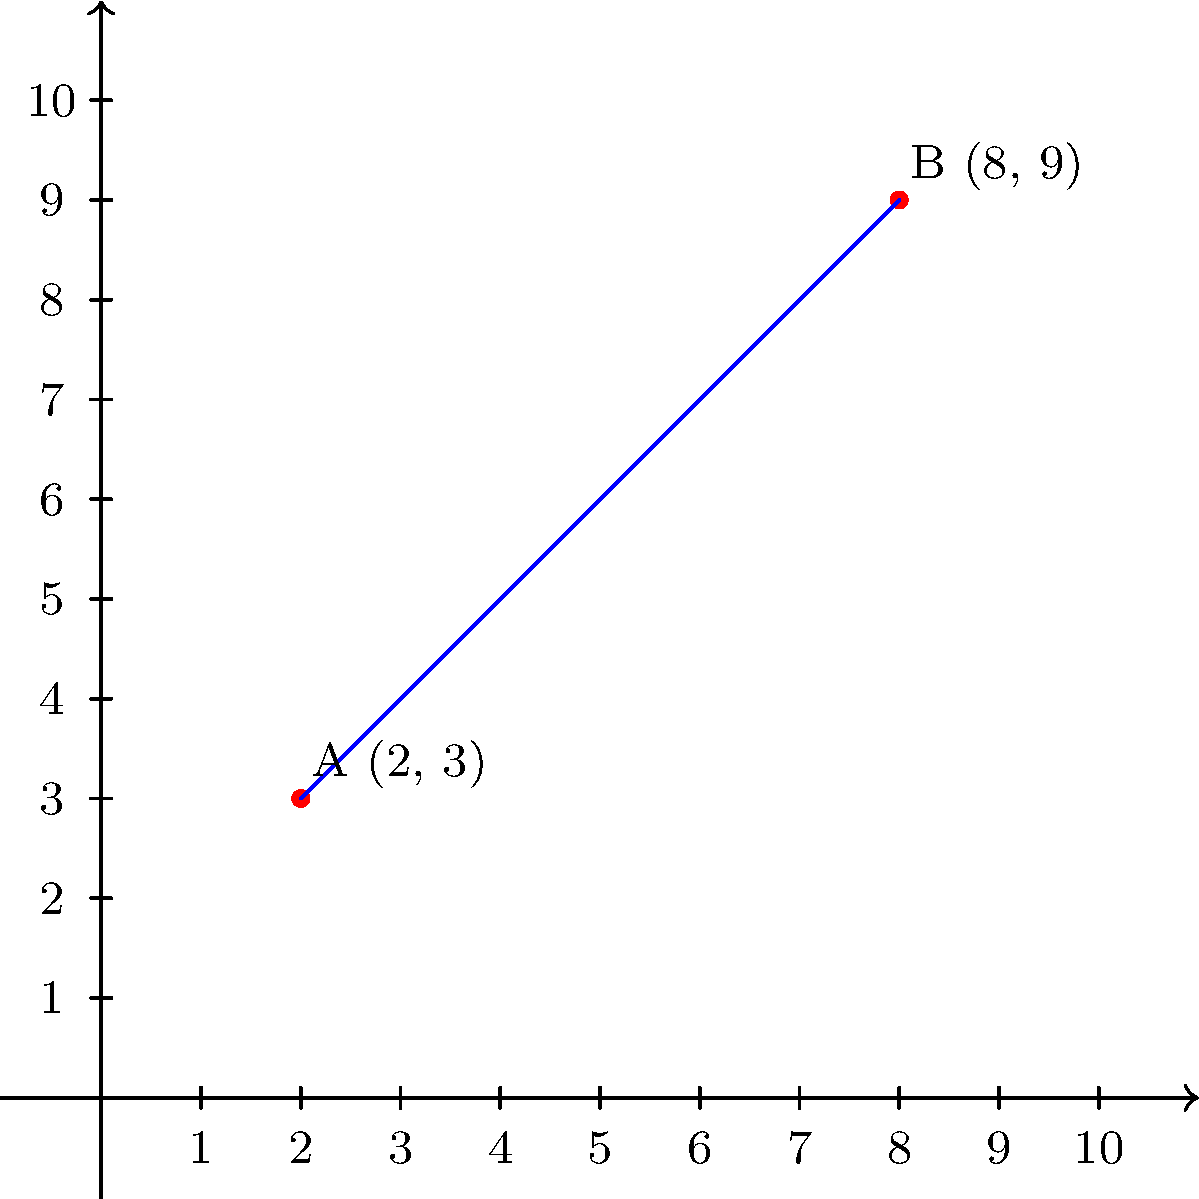Your niece is excitedly showing you her Instagram feed, pointing out two celebrity profile pictures positioned at coordinates A(2, 3) and B(8, 9) on her screen. Despite your disinterest, you decide to humor her by determining the equation of the line passing through these two points. What is the equation of this line in slope-intercept form? To find the equation of the line passing through two points, we can follow these steps:

1) First, calculate the slope (m) using the slope formula:
   $m = \frac{y_2 - y_1}{x_2 - x_1} = \frac{9 - 3}{8 - 2} = \frac{6}{6} = 1$

2) Now that we have the slope, we can use the point-slope form of a line:
   $y - y_1 = m(x - x_1)$

3) Let's use point A(2, 3). Substituting the values:
   $y - 3 = 1(x - 2)$

4) Distribute the 1:
   $y - 3 = x - 2$

5) Add 3 to both sides to isolate y:
   $y = x - 2 + 3$

6) Simplify:
   $y = x + 1$

This equation $y = x + 1$ is now in slope-intercept form $(y = mx + b)$, where $m = 1$ is the slope and $b = 1$ is the y-intercept.
Answer: $y = x + 1$ 